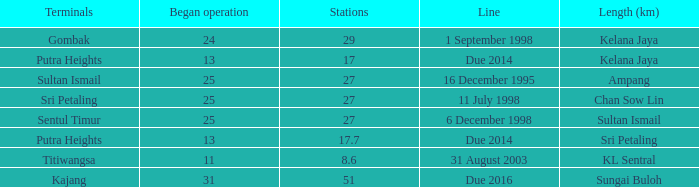What is the typical operation commencing with a length of ampang and across 27 stations? None. 